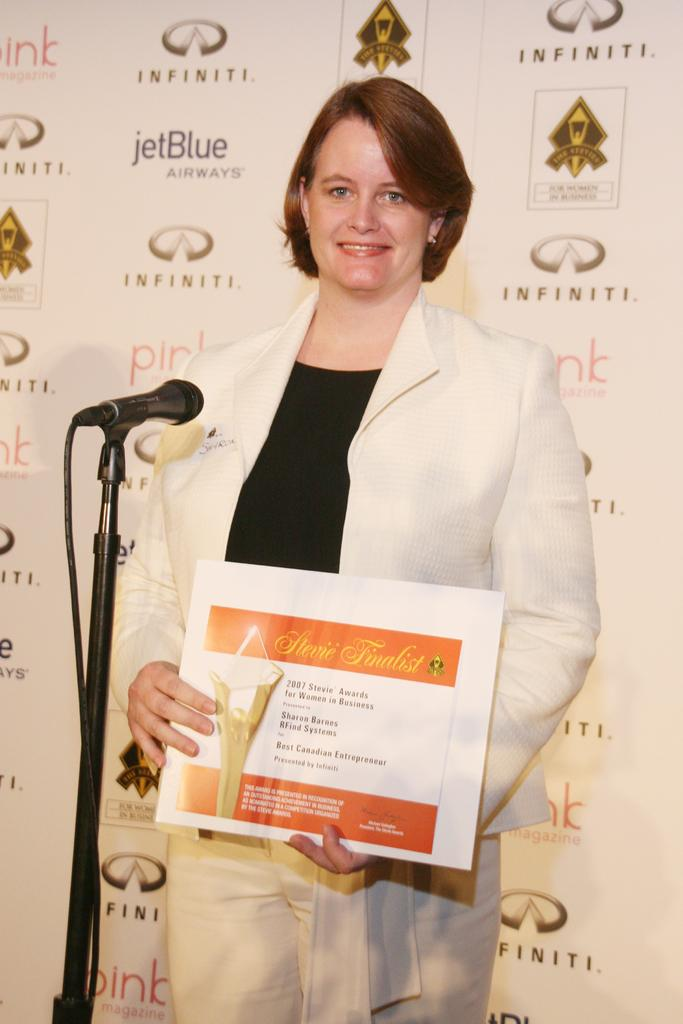Who is present in the image? There is a woman in the image. What is the woman holding in her hands? The woman is holding a frame in her hands. What is the woman's facial expression? The woman is smiling. What other object can be seen in the image? There is a microphone (mike) in the image. What is visible in the background of the image? There is a banner in the background of the image. How many friends are visible in the image? There is no friend visible in the image; it only features a woman. What type of nail is being used to hold the banner in the image? There is no nail present in the image; the banner is hanging in the background. 